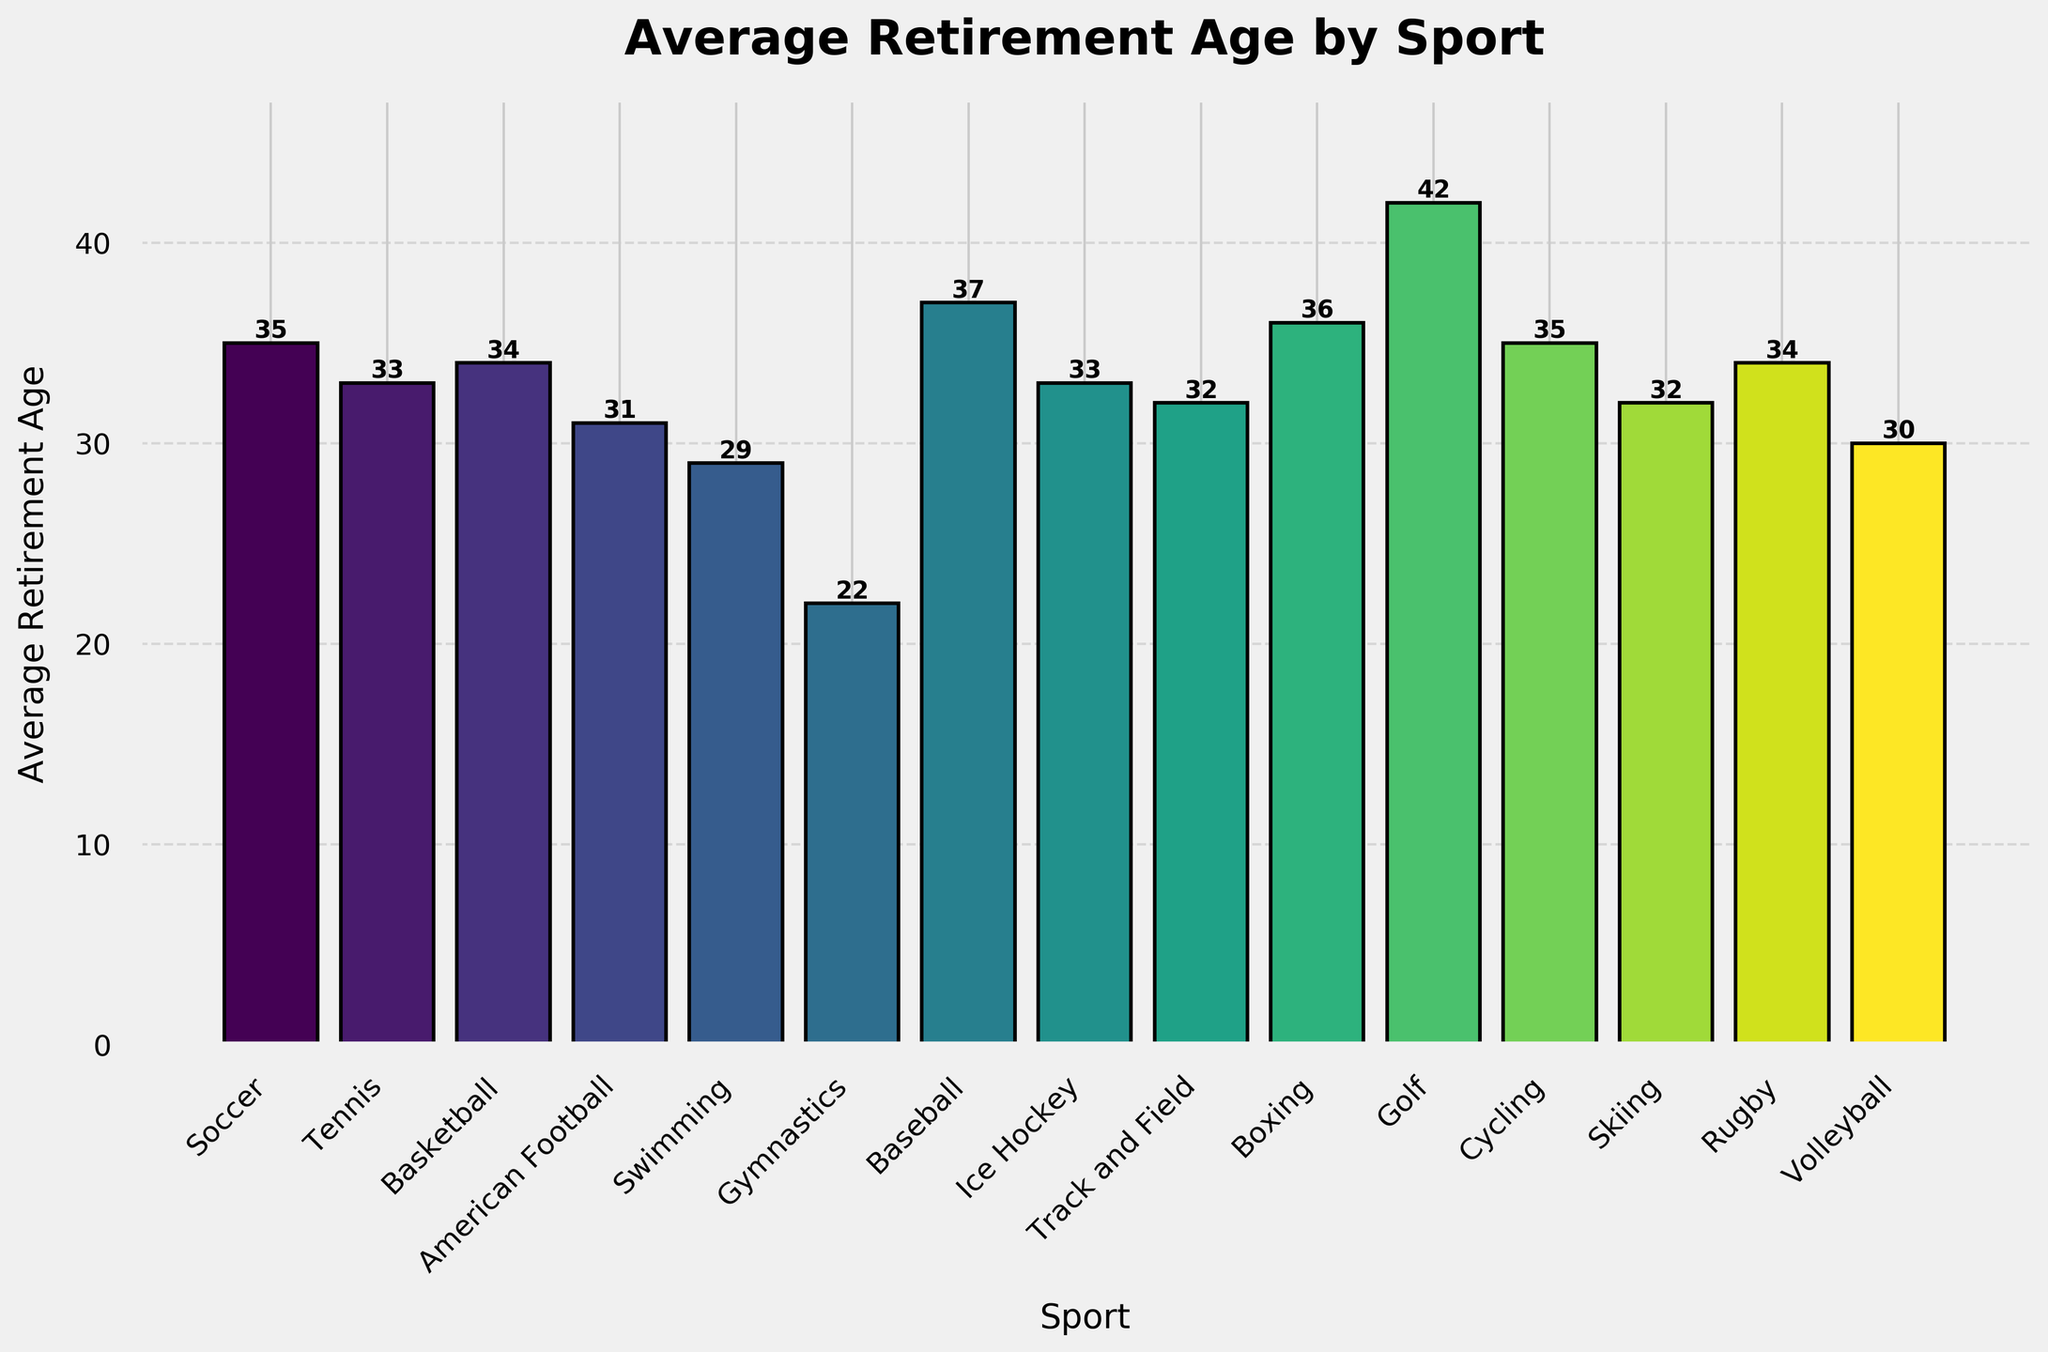What sport has the lowest average retirement age? The bar chart shows that Gymnastics has the lowest average retirement age, with the bar height indicating 22 years.
Answer: Gymnastics Which sport has the highest average retirement age and what is that age? The tallest bar in the chart represents Golf, with an average retirement age of 42 years, as denoted by the corresponding bar label.
Answer: Golf, 42 How many sports have an average retirement age above 35? By visually examining the chart, we see that only Baseball, Boxing, and Golf have bars extending above the 35-year mark, indicating an average retirement age above 35.
Answer: 3 Compare the average retirement ages of Tennis and Basketball. Which is higher and by how much? The bar for Tennis shows an average retirement age of 33 years, while Basketball shows 34 years. The difference between them is 34 - 33 = 1 year, with Basketball having the higher average retirement age.
Answer: Basketball, by 1 year What is the combined average retirement age of Swimming, Gymnastics, and Volleyball? Referring to the chart, the retirement ages for Swimming, Gymnastics, and Volleyball are 29, 22, and 30 respectively. Summing these values gives us 29 + 22 + 30 = 81.
Answer: 81 What's the difference between the highest and the lowest average retirement ages? From the chart, Golf has the highest average retirement age of 42 years and Gymnastics has the lowest at 22 years. The difference is 42 - 22 = 20 years.
Answer: 20 years What sport has an average retirement age that is closest to the overall mean retirement age? To find this, we first calculate the mean retirement age by summing all average retirement ages and dividing by the number of sports. The sum from the chart is 35+33+34+31+29+22+37+33+32+36+42+35+32+34+30 = 485, and there are 15 sports. The mean is 485 / 15 = 32.33. The closest to 32.33 is Track and Field, with an average retirement age of 32.
Answer: Track and Field Which sports have a retirement age exactly at or below 30? By checking the chart, the bars that meet this criterion are American Football (31-30=1 more), Swimming, Gymnastics, and Volleyball, indicating their retirement age is at or below 30.
Answer: Swimming, Gymnastics, Volleyball What is the average retirement age of sports that include ballgames (Soccer, Tennis, Basketball, American Football, Baseball, Ice Hockey, Rugby, Volleyball)? The retirement ages of these sports are Soccer (35), Tennis (33), Basketball (34), American Football (31), Baseball (37), Ice Hockey (33), Rugby (34), Volleyball (30). Summing these values gives 35+33+34+31+37+33+34+30 = 267. Dividing by the number of sports (8), we get the average as 267 / 8 = 33.375.
Answer: 33.375 Which sport has an average retirement age that matches the median value of the provided data? Ordering the values, we get: 22, 29, 30, 31, 32, 32, 33, 33, 34, 34, 35, 35, 36, 37, 42. With 15 values, the median is the 8th one. The 8th value is 33, matched by Tennis and Ice Hockey.
Answer: Tennis, Ice Hockey 